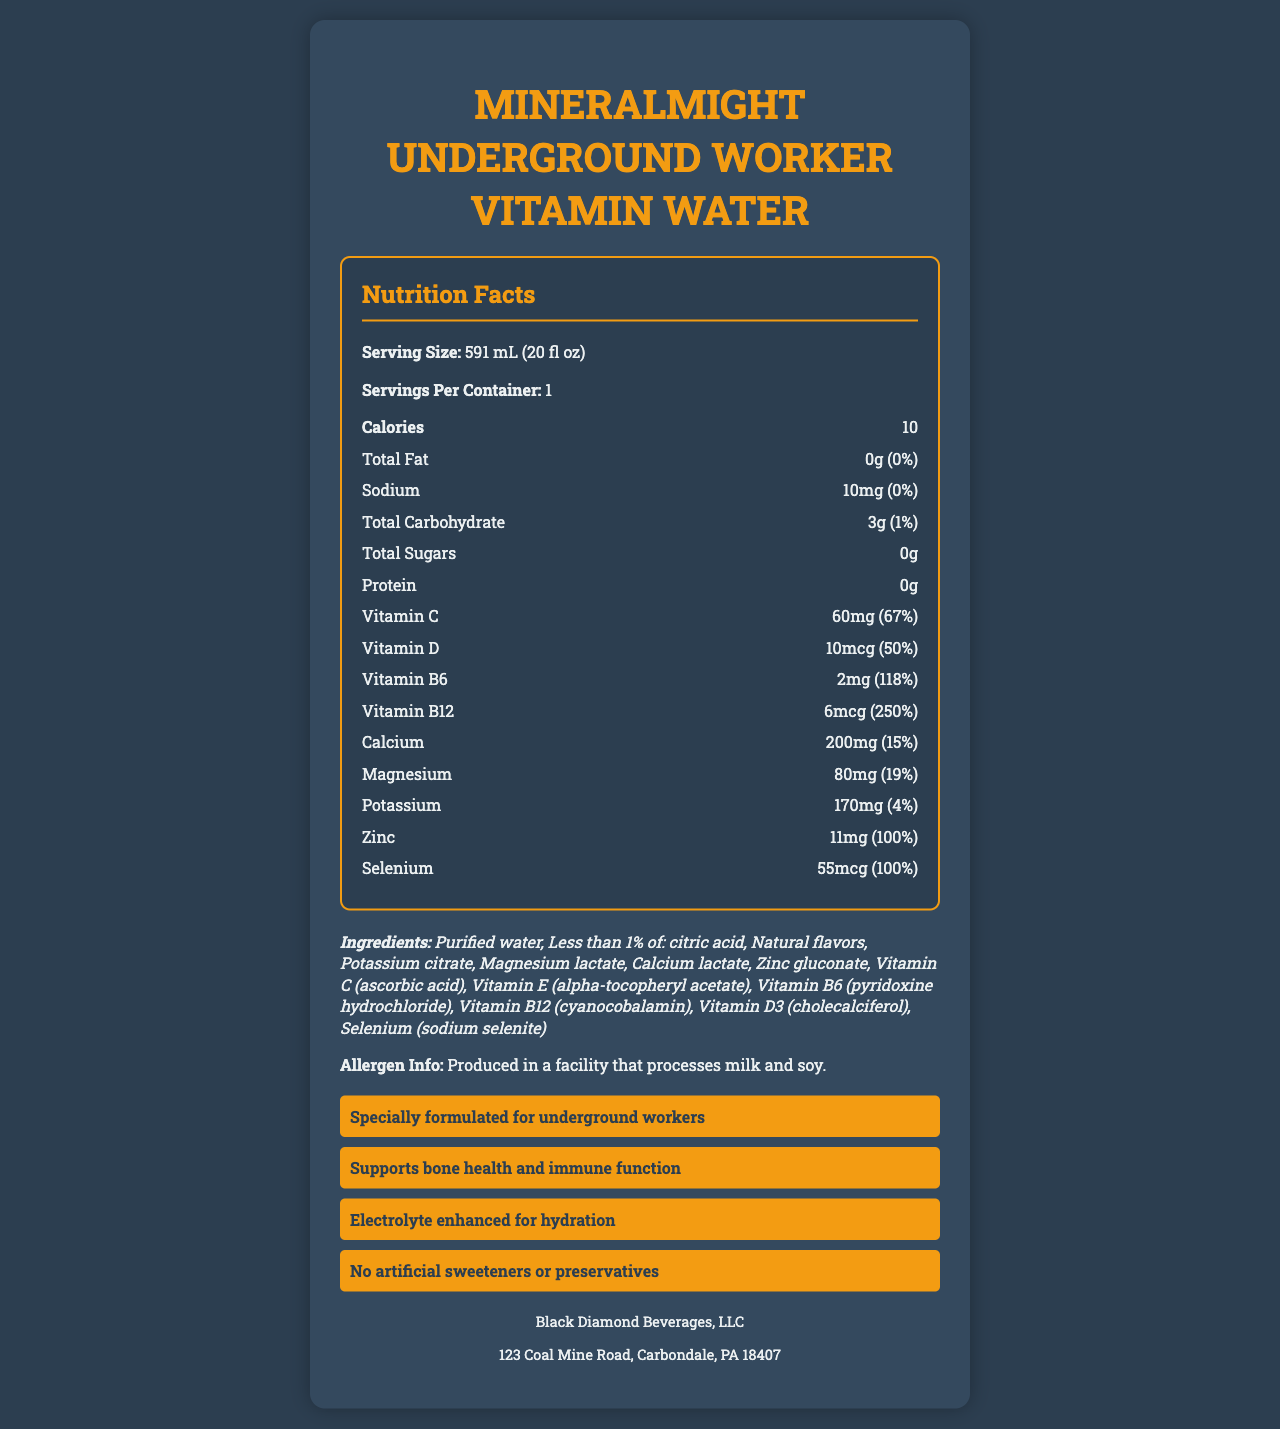what is the serving size? The serving size is explicitly stated as "591 mL (20 fl oz)" on the nutrition label.
Answer: 591 mL (20 fl oz) how many calories does a serving contain? The number of calories per serving is mentioned as 10 calories on the nutrition label.
Answer: 10 calories what is the amount and daily value percentage of Vitamin C? The nutrition label states that Vitamin C is present in an amount of 60mg, which is 67% of the daily value.
Answer: 60mg (67%) what company manufactures MineralMight Underground Worker Vitamin Water? The manufacturer is listed as "Black Diamond Beverages, LLC" on the document.
Answer: Black Diamond Beverages, LLC how much protein is in a serving? The nutrition label shows that a serving contains 0 grams of protein.
Answer: 0g what is the total fat content? A. 0g B. 1g C. 2g D. 3g The nutrition label indicates that the total fat content in a serving is 0 grams.
Answer: A. 0g which of the following is a claim made about the product? A. Gluten-free B. No added sugar C. Supports bone health D. High in fiber The document lists "Supports bone health and immune function" as one of the product claims.
Answer: C. Supports bone health does the product contain any sugars? The label shows "Total Sugars: 0g" indicating that the product does not contain any sugars.
Answer: No summarize the main idea of the document. The main idea encapsulates all aspects of the nutrition facts, ingredients, claims, manufacturer, and allergen information as presented in the document.
Answer: The document presents the nutrition facts for MineralMight Underground Worker Vitamin Water, a vitamin-fortified water designed for underground workers, including detailed nutrient content, ingredients, claims, allergen information, and manufacturer details. is the product free from artificial sweeteners and preservatives? One of the claims listed in the document is "No artificial sweeteners or preservatives".
Answer: Yes what is the exact address of the manufacturer? The manufacturer's address is provided as "123 Coal Mine Road, Carbondale, PA 18407" in the document.
Answer: 123 Coal Mine Road, Carbondale, PA 18407 how much sodium does the product contain? The nutrition label indicates that the product contains 10mg of sodium.
Answer: 10mg which vitamin has the highest daily value percentage? The label shows that Vitamin B12 has a daily value percentage of 250%, which is the highest among the listed vitamins and minerals.
Answer: Vitamin B12 (250%) what are the first three ingredients listed? According to the ingredients list, the first three items are: Purified water, Less than 1% of: citric acid, Natural flavors.
Answer: Purified water, Less than 1% of: citric acid, Natural flavors is the product intended to be consumed by underground workers only? The label specifies that it is "specially formulated for underground workers," but it does not state that it is exclusively for them.
Answer: Cannot be determined 